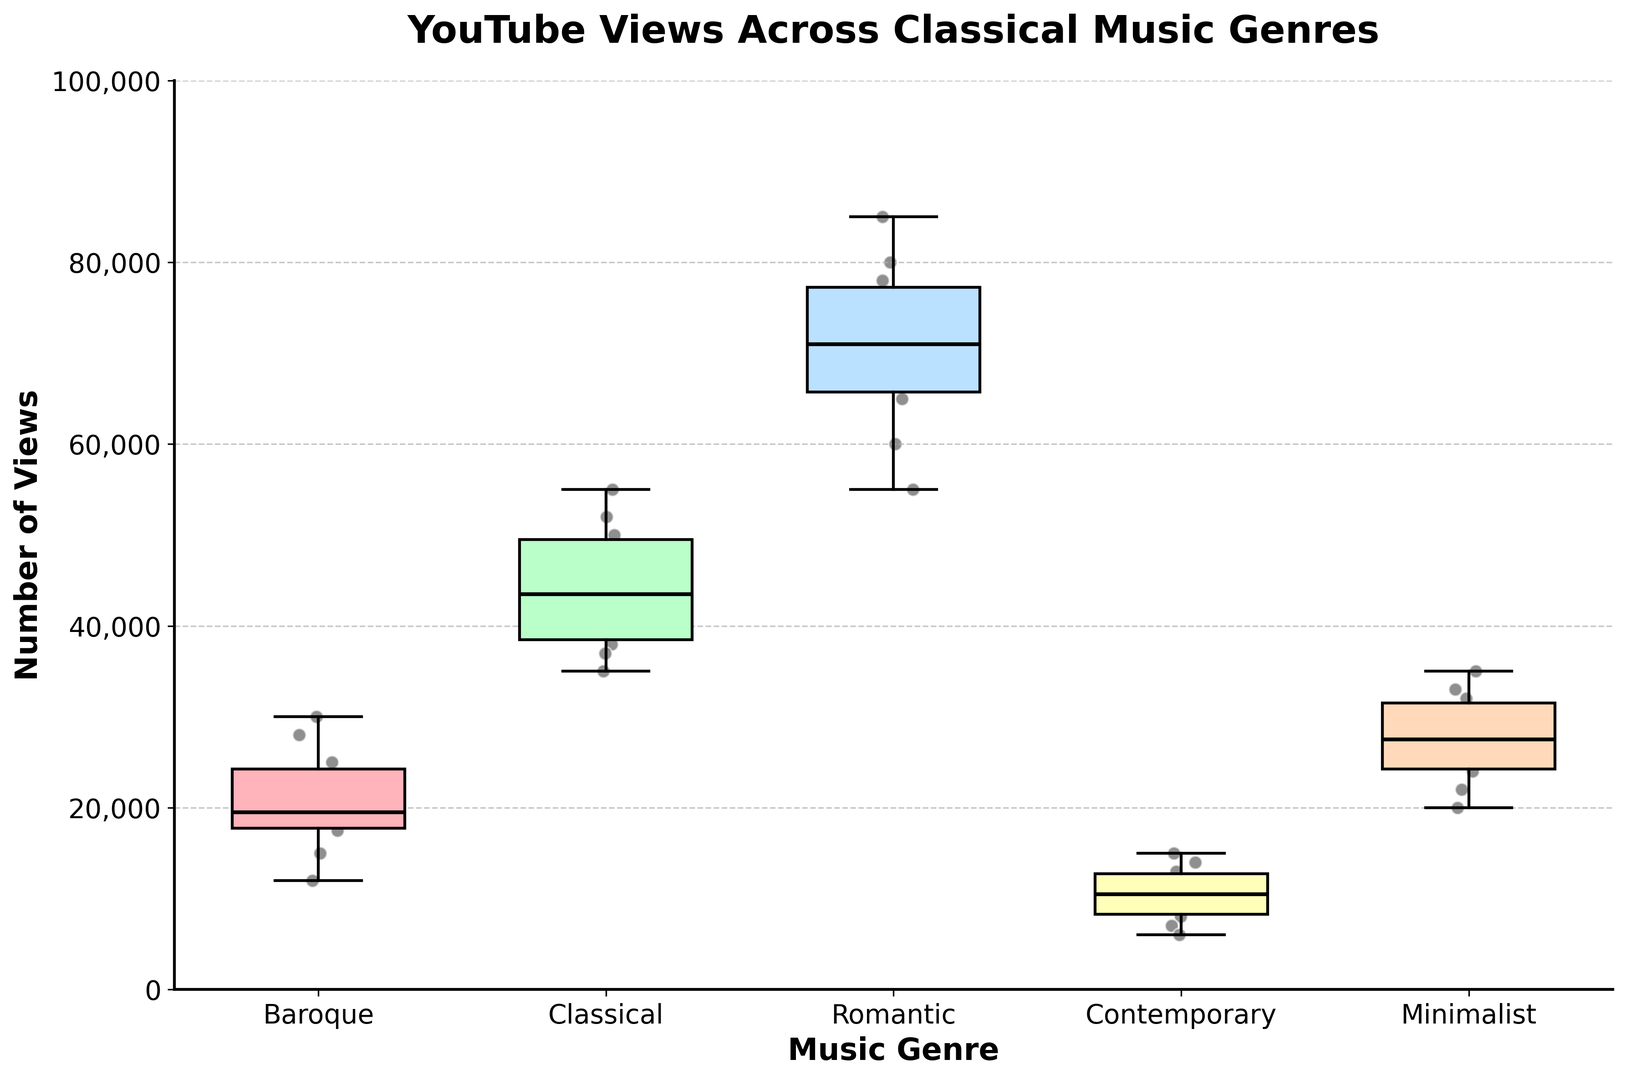What is the median number of views for the Romantic genre? Look at the box plot for the Romantic genre and find the line inside the box which represents the median value.
Answer: 70,000 Which genre has the highest upper whisker value and what is the value? The upper whisker is the highest line extending from the box. By comparing the whiskers, the Romantic genre has the highest upper whisker when compared to other genres.
Answer: Romantic, 85,000 Which genre has the smallest range of views? The range is the difference between the top and bottom whiskers. The Contemporary genre shows the smallest range since it has the lowest spread compared to other genres.
Answer: Contemporary What are the interquartile ranges (IQR) for the Classical and Minimalist genres? IQR is the range between the first (bottom of the box) and third (top of the box) quartiles. For Classical, the IQR is from 38,000 to 50,000. For Minimalist, it is from 25,000 to 32,000.
Answer: Classical: 12,000; Minimalist: 7,000 What genre has the highest median number of views? The median is the middle line inside each box. The Romantic genre has the highest median line compared to other genres.
Answer: Romantic For the Baroque genre, what is the approximate interquartile range (IQR)? The IQR is found between the bottom and top edges of the box. For Baroque, this range is from approximately 17,500 to 25,000.
Answer: 7,500 Which genre has the smallest median number of views and what is that value? Compare the median lines across all box plots. The Contemporary genre has the smallest median line.
Answer: Contemporary, 10,000 In terms of outliers, which genre shows the most outliers and how many? Outliers are individual points scattered outside the whiskers. The Contemporary genre has three such points (below the lower whisker, indicating 3 outliers).
Answer: Contemporary, 3 